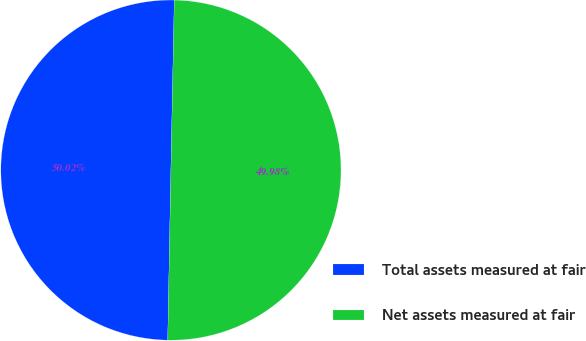Convert chart to OTSL. <chart><loc_0><loc_0><loc_500><loc_500><pie_chart><fcel>Total assets measured at fair<fcel>Net assets measured at fair<nl><fcel>50.02%<fcel>49.98%<nl></chart> 